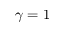<formula> <loc_0><loc_0><loc_500><loc_500>\gamma = 1</formula> 